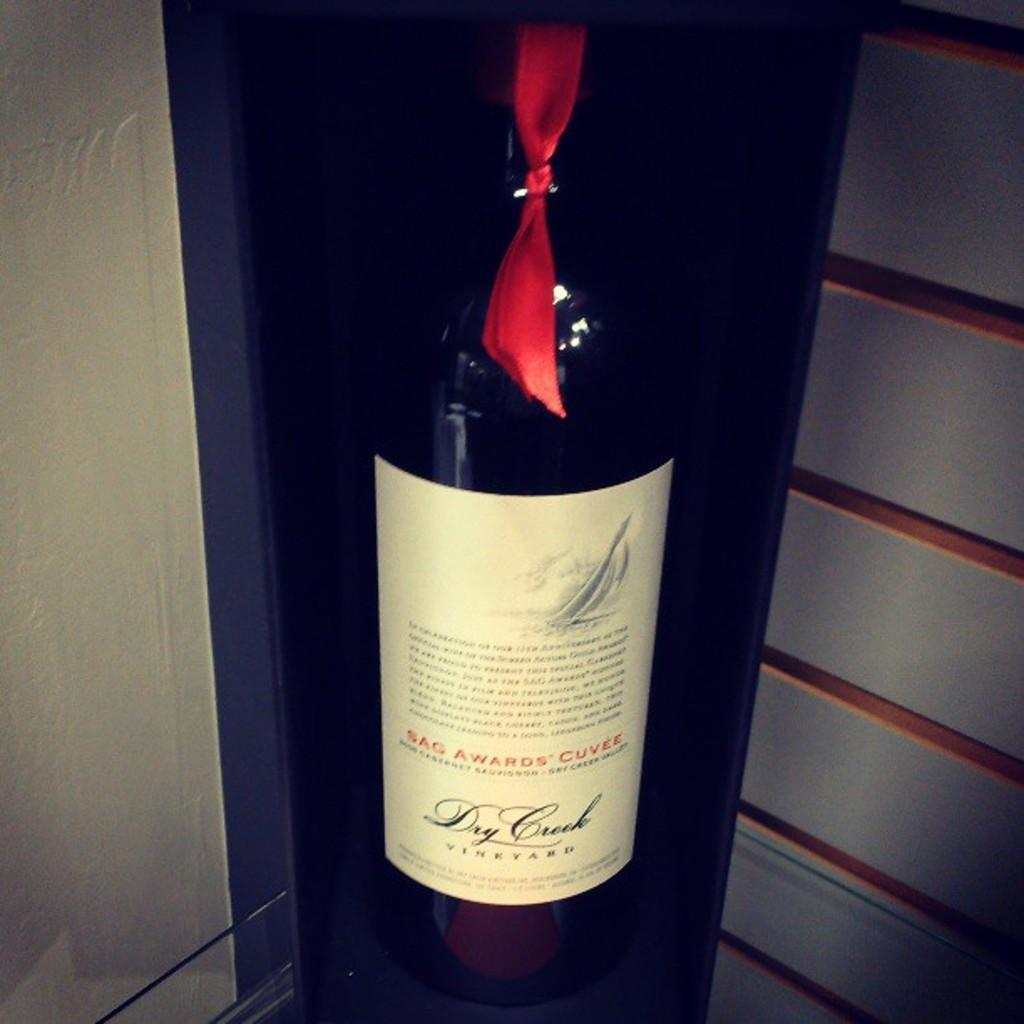<image>
Write a terse but informative summary of the picture. a wine bottle with the word dry on it 